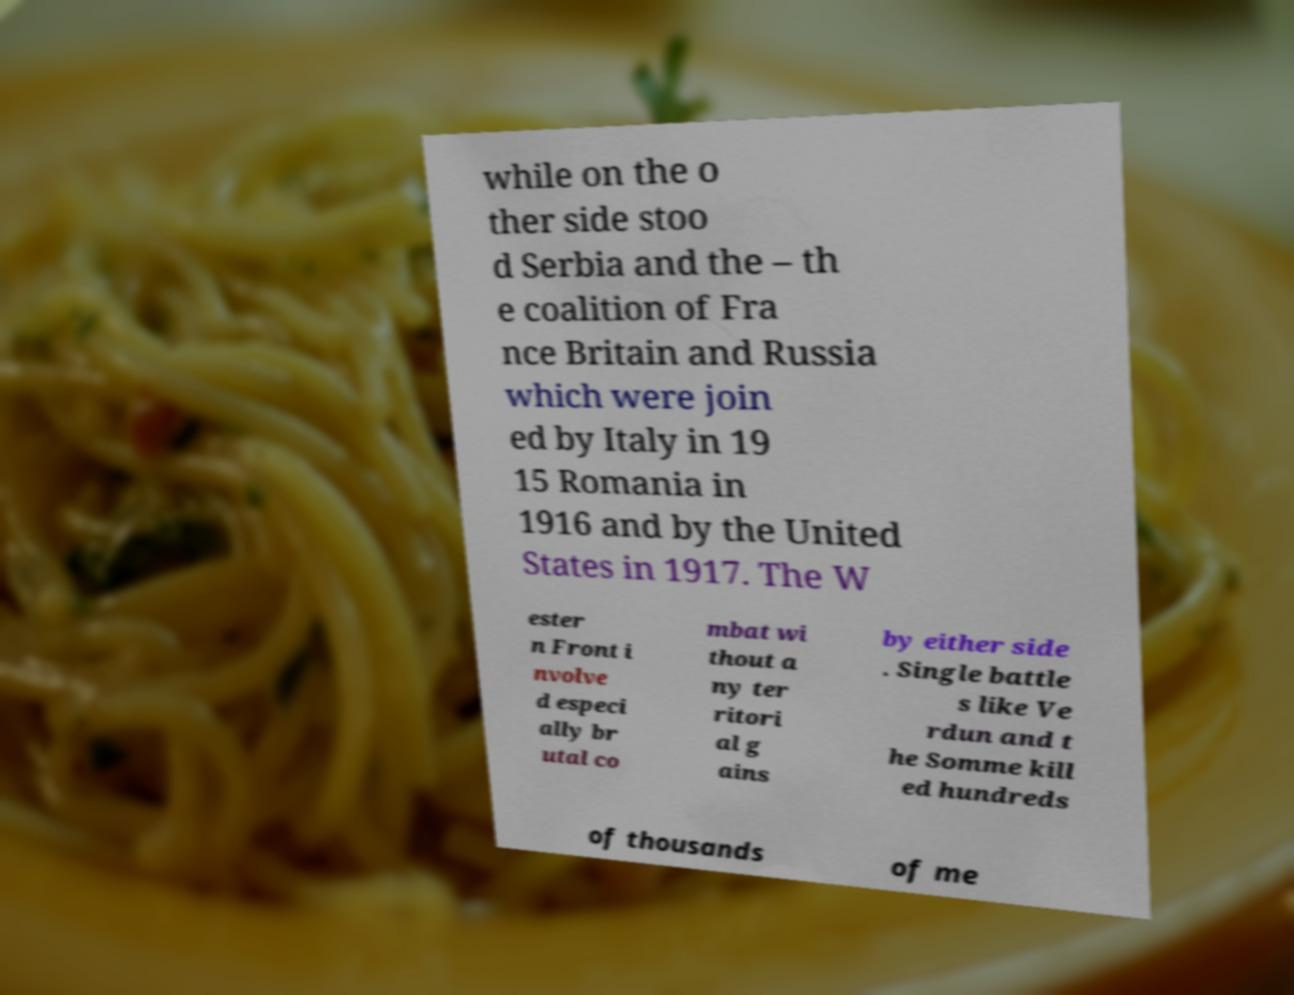For documentation purposes, I need the text within this image transcribed. Could you provide that? while on the o ther side stoo d Serbia and the – th e coalition of Fra nce Britain and Russia which were join ed by Italy in 19 15 Romania in 1916 and by the United States in 1917. The W ester n Front i nvolve d especi ally br utal co mbat wi thout a ny ter ritori al g ains by either side . Single battle s like Ve rdun and t he Somme kill ed hundreds of thousands of me 